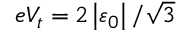<formula> <loc_0><loc_0><loc_500><loc_500>e V _ { t } = 2 \left | \varepsilon _ { 0 } \right | / \sqrt { 3 }</formula> 